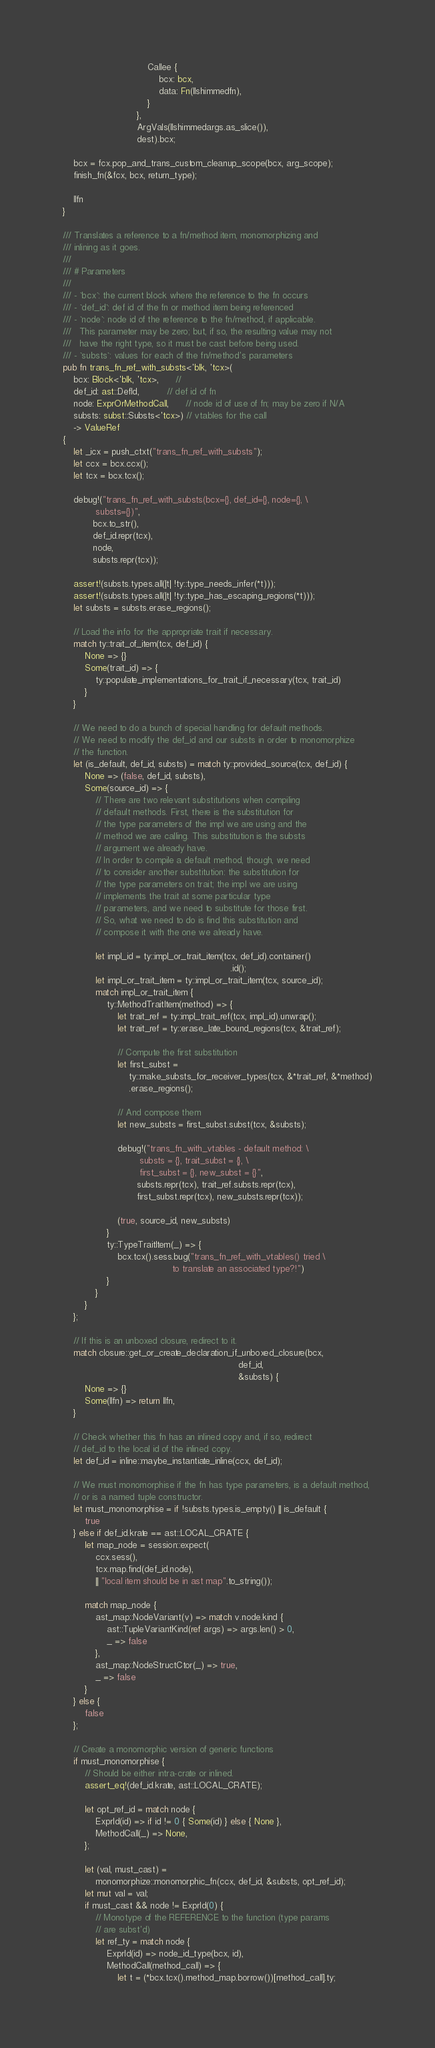Convert code to text. <code><loc_0><loc_0><loc_500><loc_500><_Rust_>                               Callee {
                                   bcx: bcx,
                                   data: Fn(llshimmedfn),
                               }
                           },
                           ArgVals(llshimmedargs.as_slice()),
                           dest).bcx;

    bcx = fcx.pop_and_trans_custom_cleanup_scope(bcx, arg_scope);
    finish_fn(&fcx, bcx, return_type);

    llfn
}

/// Translates a reference to a fn/method item, monomorphizing and
/// inlining as it goes.
///
/// # Parameters
///
/// - `bcx`: the current block where the reference to the fn occurs
/// - `def_id`: def id of the fn or method item being referenced
/// - `node`: node id of the reference to the fn/method, if applicable.
///   This parameter may be zero; but, if so, the resulting value may not
///   have the right type, so it must be cast before being used.
/// - `substs`: values for each of the fn/method's parameters
pub fn trans_fn_ref_with_substs<'blk, 'tcx>(
    bcx: Block<'blk, 'tcx>,      //
    def_id: ast::DefId,          // def id of fn
    node: ExprOrMethodCall,      // node id of use of fn; may be zero if N/A
    substs: subst::Substs<'tcx>) // vtables for the call
    -> ValueRef
{
    let _icx = push_ctxt("trans_fn_ref_with_substs");
    let ccx = bcx.ccx();
    let tcx = bcx.tcx();

    debug!("trans_fn_ref_with_substs(bcx={}, def_id={}, node={}, \
            substs={})",
           bcx.to_str(),
           def_id.repr(tcx),
           node,
           substs.repr(tcx));

    assert!(substs.types.all(|t| !ty::type_needs_infer(*t)));
    assert!(substs.types.all(|t| !ty::type_has_escaping_regions(*t)));
    let substs = substs.erase_regions();

    // Load the info for the appropriate trait if necessary.
    match ty::trait_of_item(tcx, def_id) {
        None => {}
        Some(trait_id) => {
            ty::populate_implementations_for_trait_if_necessary(tcx, trait_id)
        }
    }

    // We need to do a bunch of special handling for default methods.
    // We need to modify the def_id and our substs in order to monomorphize
    // the function.
    let (is_default, def_id, substs) = match ty::provided_source(tcx, def_id) {
        None => (false, def_id, substs),
        Some(source_id) => {
            // There are two relevant substitutions when compiling
            // default methods. First, there is the substitution for
            // the type parameters of the impl we are using and the
            // method we are calling. This substitution is the substs
            // argument we already have.
            // In order to compile a default method, though, we need
            // to consider another substitution: the substitution for
            // the type parameters on trait; the impl we are using
            // implements the trait at some particular type
            // parameters, and we need to substitute for those first.
            // So, what we need to do is find this substitution and
            // compose it with the one we already have.

            let impl_id = ty::impl_or_trait_item(tcx, def_id).container()
                                                             .id();
            let impl_or_trait_item = ty::impl_or_trait_item(tcx, source_id);
            match impl_or_trait_item {
                ty::MethodTraitItem(method) => {
                    let trait_ref = ty::impl_trait_ref(tcx, impl_id).unwrap();
                    let trait_ref = ty::erase_late_bound_regions(tcx, &trait_ref);

                    // Compute the first substitution
                    let first_subst =
                        ty::make_substs_for_receiver_types(tcx, &*trait_ref, &*method)
                        .erase_regions();

                    // And compose them
                    let new_substs = first_subst.subst(tcx, &substs);

                    debug!("trans_fn_with_vtables - default method: \
                            substs = {}, trait_subst = {}, \
                            first_subst = {}, new_subst = {}",
                           substs.repr(tcx), trait_ref.substs.repr(tcx),
                           first_subst.repr(tcx), new_substs.repr(tcx));

                    (true, source_id, new_substs)
                }
                ty::TypeTraitItem(_) => {
                    bcx.tcx().sess.bug("trans_fn_ref_with_vtables() tried \
                                        to translate an associated type?!")
                }
            }
        }
    };

    // If this is an unboxed closure, redirect to it.
    match closure::get_or_create_declaration_if_unboxed_closure(bcx,
                                                                def_id,
                                                                &substs) {
        None => {}
        Some(llfn) => return llfn,
    }

    // Check whether this fn has an inlined copy and, if so, redirect
    // def_id to the local id of the inlined copy.
    let def_id = inline::maybe_instantiate_inline(ccx, def_id);

    // We must monomorphise if the fn has type parameters, is a default method,
    // or is a named tuple constructor.
    let must_monomorphise = if !substs.types.is_empty() || is_default {
        true
    } else if def_id.krate == ast::LOCAL_CRATE {
        let map_node = session::expect(
            ccx.sess(),
            tcx.map.find(def_id.node),
            || "local item should be in ast map".to_string());

        match map_node {
            ast_map::NodeVariant(v) => match v.node.kind {
                ast::TupleVariantKind(ref args) => args.len() > 0,
                _ => false
            },
            ast_map::NodeStructCtor(_) => true,
            _ => false
        }
    } else {
        false
    };

    // Create a monomorphic version of generic functions
    if must_monomorphise {
        // Should be either intra-crate or inlined.
        assert_eq!(def_id.krate, ast::LOCAL_CRATE);

        let opt_ref_id = match node {
            ExprId(id) => if id != 0 { Some(id) } else { None },
            MethodCall(_) => None,
        };

        let (val, must_cast) =
            monomorphize::monomorphic_fn(ccx, def_id, &substs, opt_ref_id);
        let mut val = val;
        if must_cast && node != ExprId(0) {
            // Monotype of the REFERENCE to the function (type params
            // are subst'd)
            let ref_ty = match node {
                ExprId(id) => node_id_type(bcx, id),
                MethodCall(method_call) => {
                    let t = (*bcx.tcx().method_map.borrow())[method_call].ty;</code> 